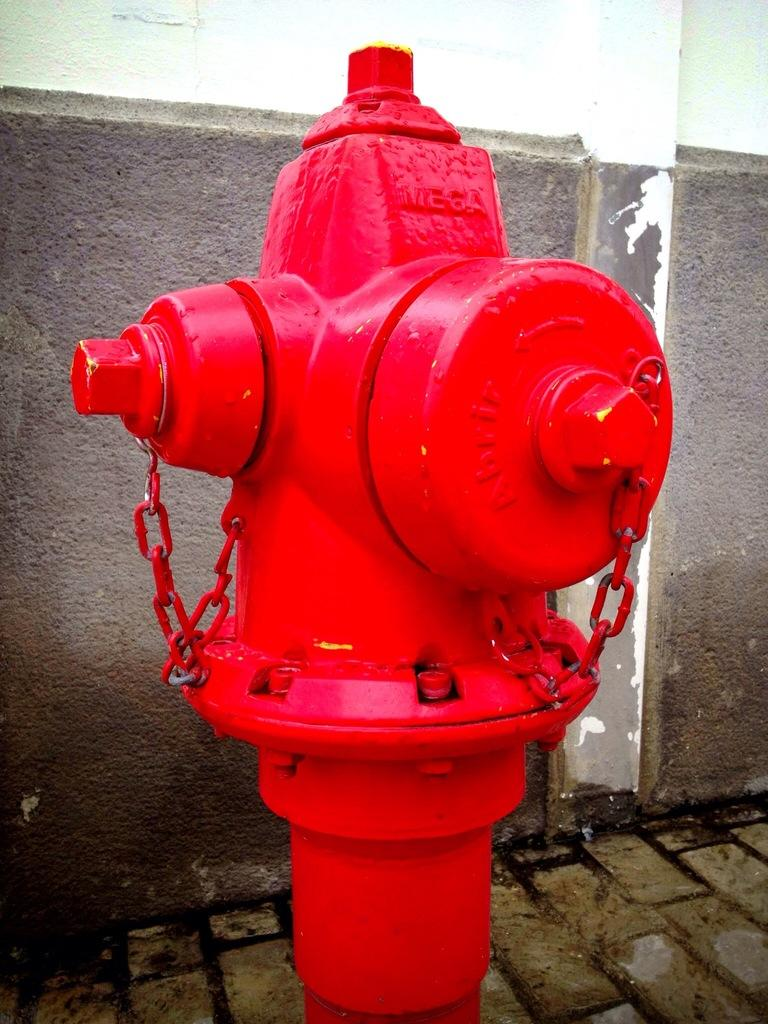What is the color of the pole in the image? The pole in the image is red. What is attached to the pole? The pole has chains and nuts attached to it. What can be seen in the background of the image? There is a footpath and a wall in the background of the image. What type of polish is being applied to the wall in the image? There is no indication of any polish being applied to the wall in the image. 